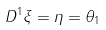<formula> <loc_0><loc_0><loc_500><loc_500>D ^ { 1 } \xi = \eta = \theta _ { 1 }</formula> 